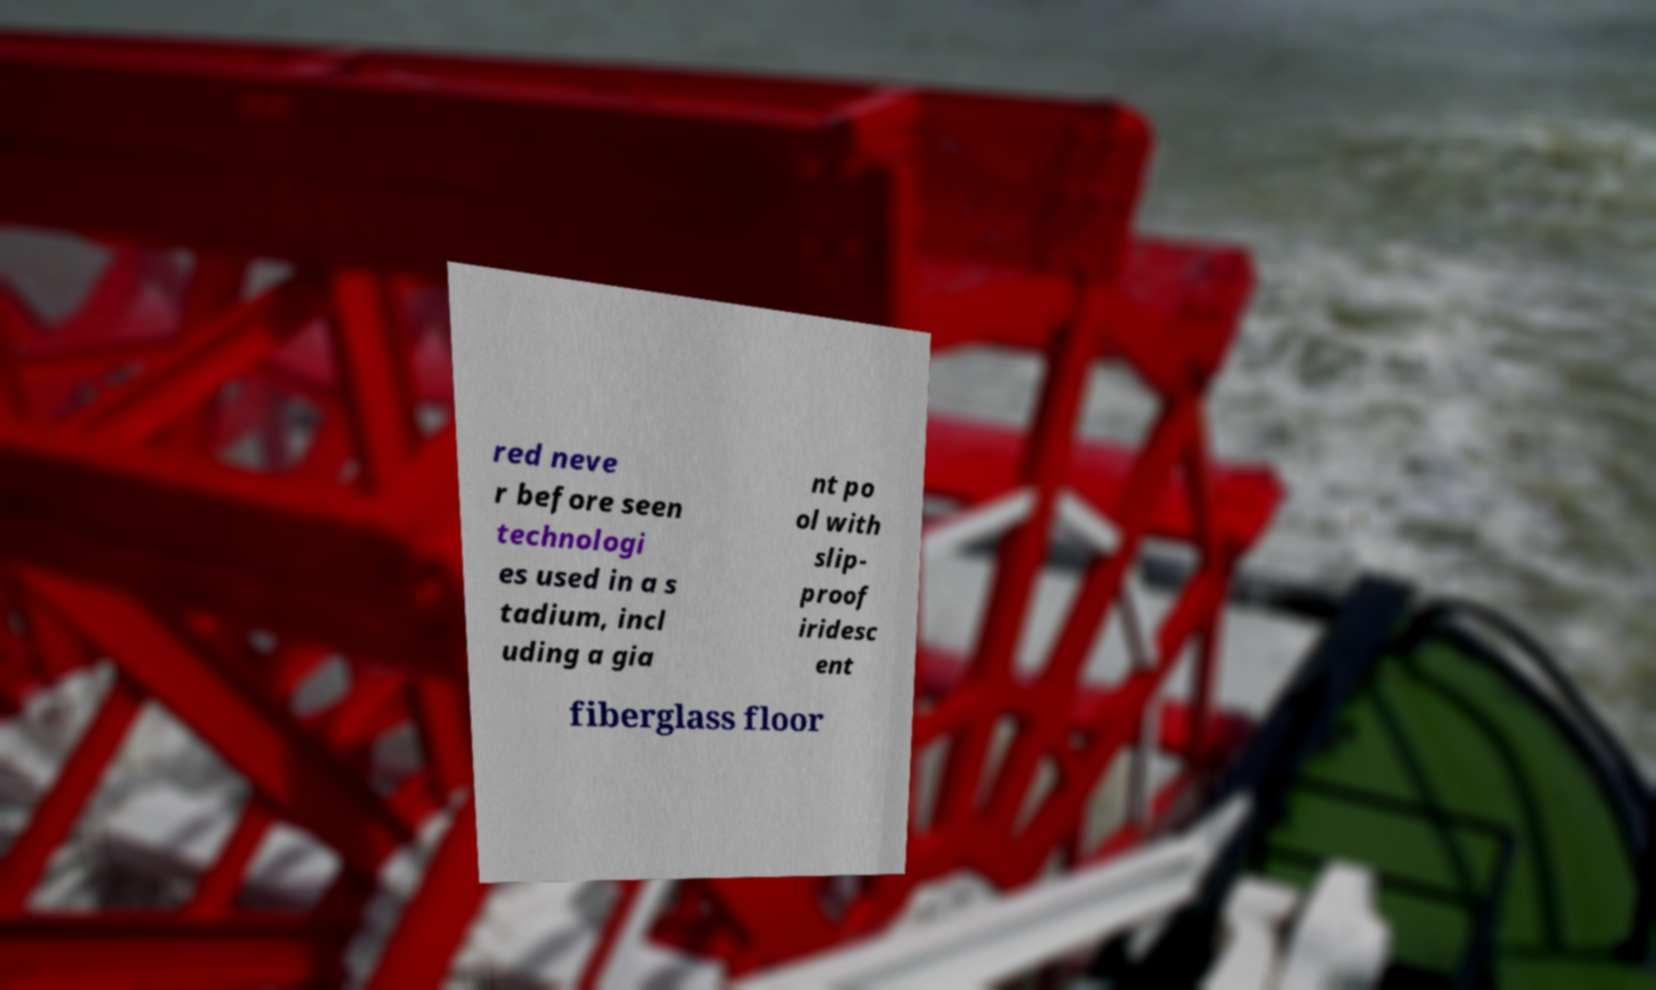For documentation purposes, I need the text within this image transcribed. Could you provide that? red neve r before seen technologi es used in a s tadium, incl uding a gia nt po ol with slip- proof iridesc ent fiberglass floor 